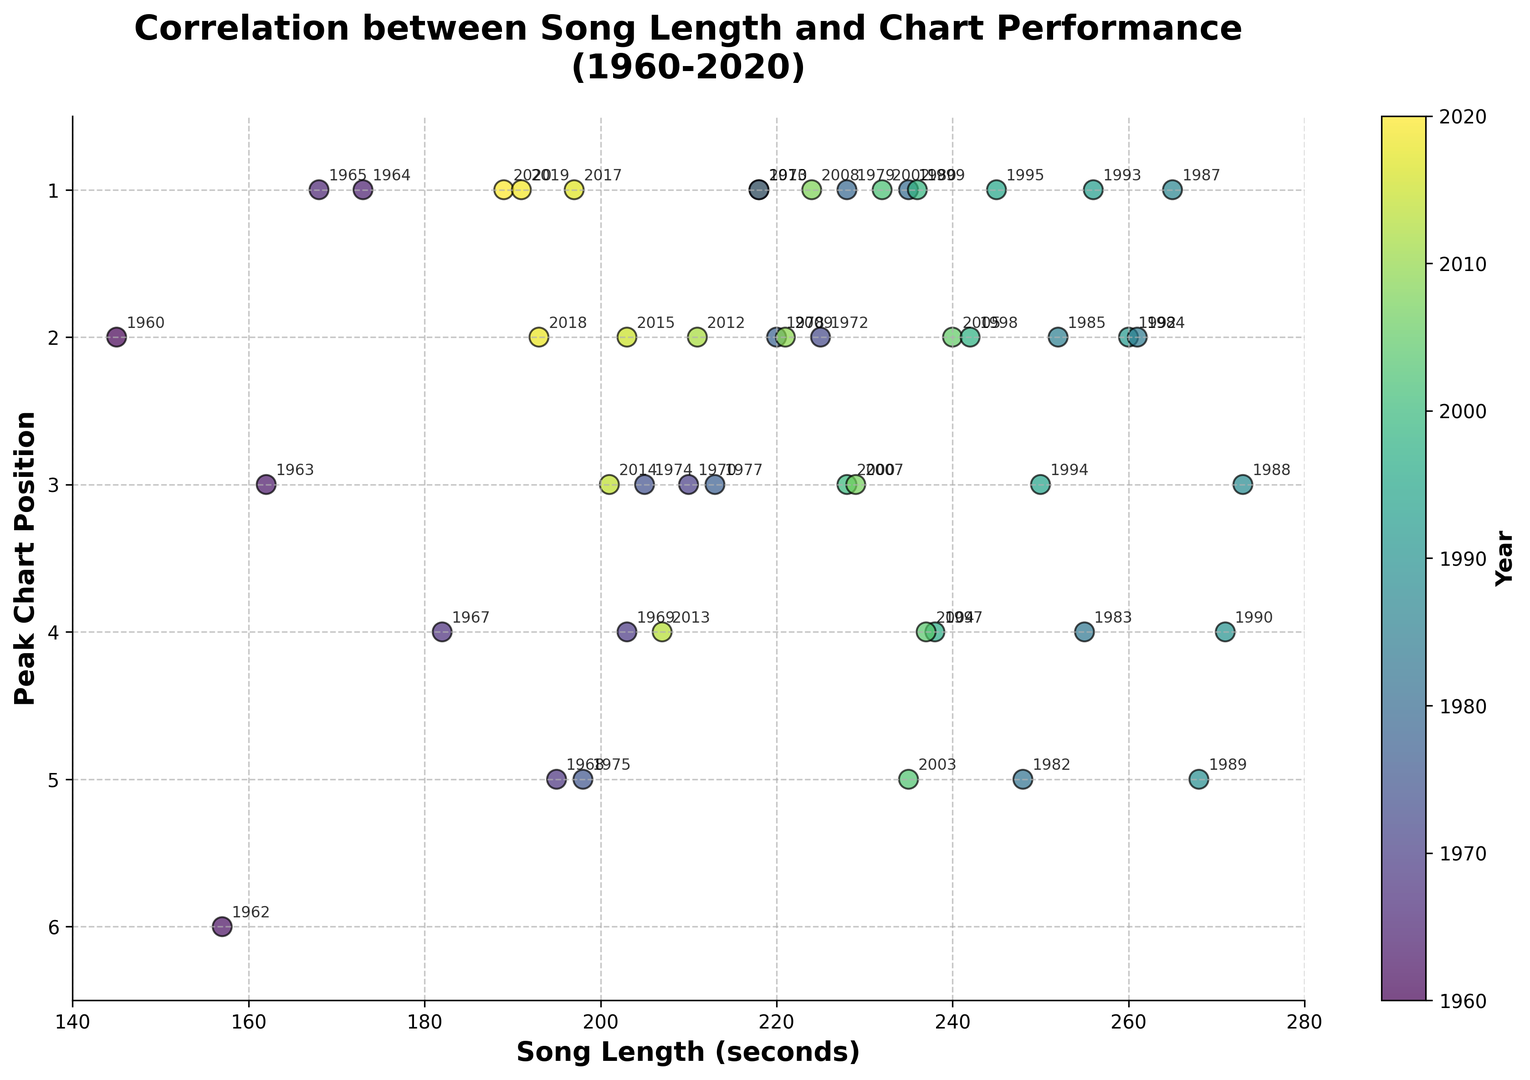How does the song length correlate with chart performance over the years? By observing the scatter plot, there is no straightforward linear trend between song length and chart performance over the years. Instead, various song lengths have achieved high chart positions across different years. This indicates that other factors besides song length likely play a crucial role in determining chart performance.
Answer: No clear correlation Which year had the longest song in the top position on the chart? To find this, look for the year with the chart position of 1 and the longest song length. The data point at the position (273, 1) corresponds to the year 1987. Thus, in 1987, the longest song at the top position on the chart was 273 seconds long.
Answer: 1987 Is there a trend in terms of song length getting shorter or longer over the years? By examining the colors representing years, we can see a gradual trend. Songs from the 1960s to the early 2000s tend to be longer, while more recent songs (2010 onwards) show a trend towards shorter lengths. This suggests a general trend of shorter song lengths in more recent years.
Answer: Shorter What is the range of song lengths that achieved the peak chart position of 1? We need to look for all data points with a peak chart position of 1 on the y-axis and note their song lengths. The song lengths for the top position range from approximately 168 seconds (1965) to 273 seconds (1987).
Answer: 168 to 273 seconds Are peak chart positions more distributed across the years or concentrated in particular years? The scatter plot shows a uniform distribution of peak chart positions across years, without a concentration in any specific year. This implies that achieving top chart positions is consistently tough across different years.
Answer: Distributed Which era seemed to favor longer songs charting higher? Color coding indicates longer songs (over 250 seconds) in the top chart positions during the 1980s through the early 2000s. Specifically, years like 1983, 1984, and 1985 had longer songs which performed well on the charts.
Answer: 1980s-2000s Compare the average song length of the top position in the 1960s versus the 2010s. To compare, find the data points where the peak position is 1 in the 1960s and the 2010s. The 1960s have lengths of 145, 168, and 173 seconds, with an average of 162 seconds. The 2010s have lengths of 218, 197, 189, and 191 seconds, averaging 198.75 seconds. Hence, the average song length was shorter in the 1960s.
Answer: 162 seconds vs. 198.75 seconds How many songs in the chart had a length of 230 seconds or longer in the top 5 positions? Count the data points where the song length is 230 seconds or longer and the peak chart position is 5 or better (<=5 on the y-axis). We see several such data points: 1980 (235s, 1), 1982 (248s, 5), 1983 (255s, 4), 1987 (265s, 1), 1988 (273s, 3), 1990 (271s, 4).
Answer: 6 songs 